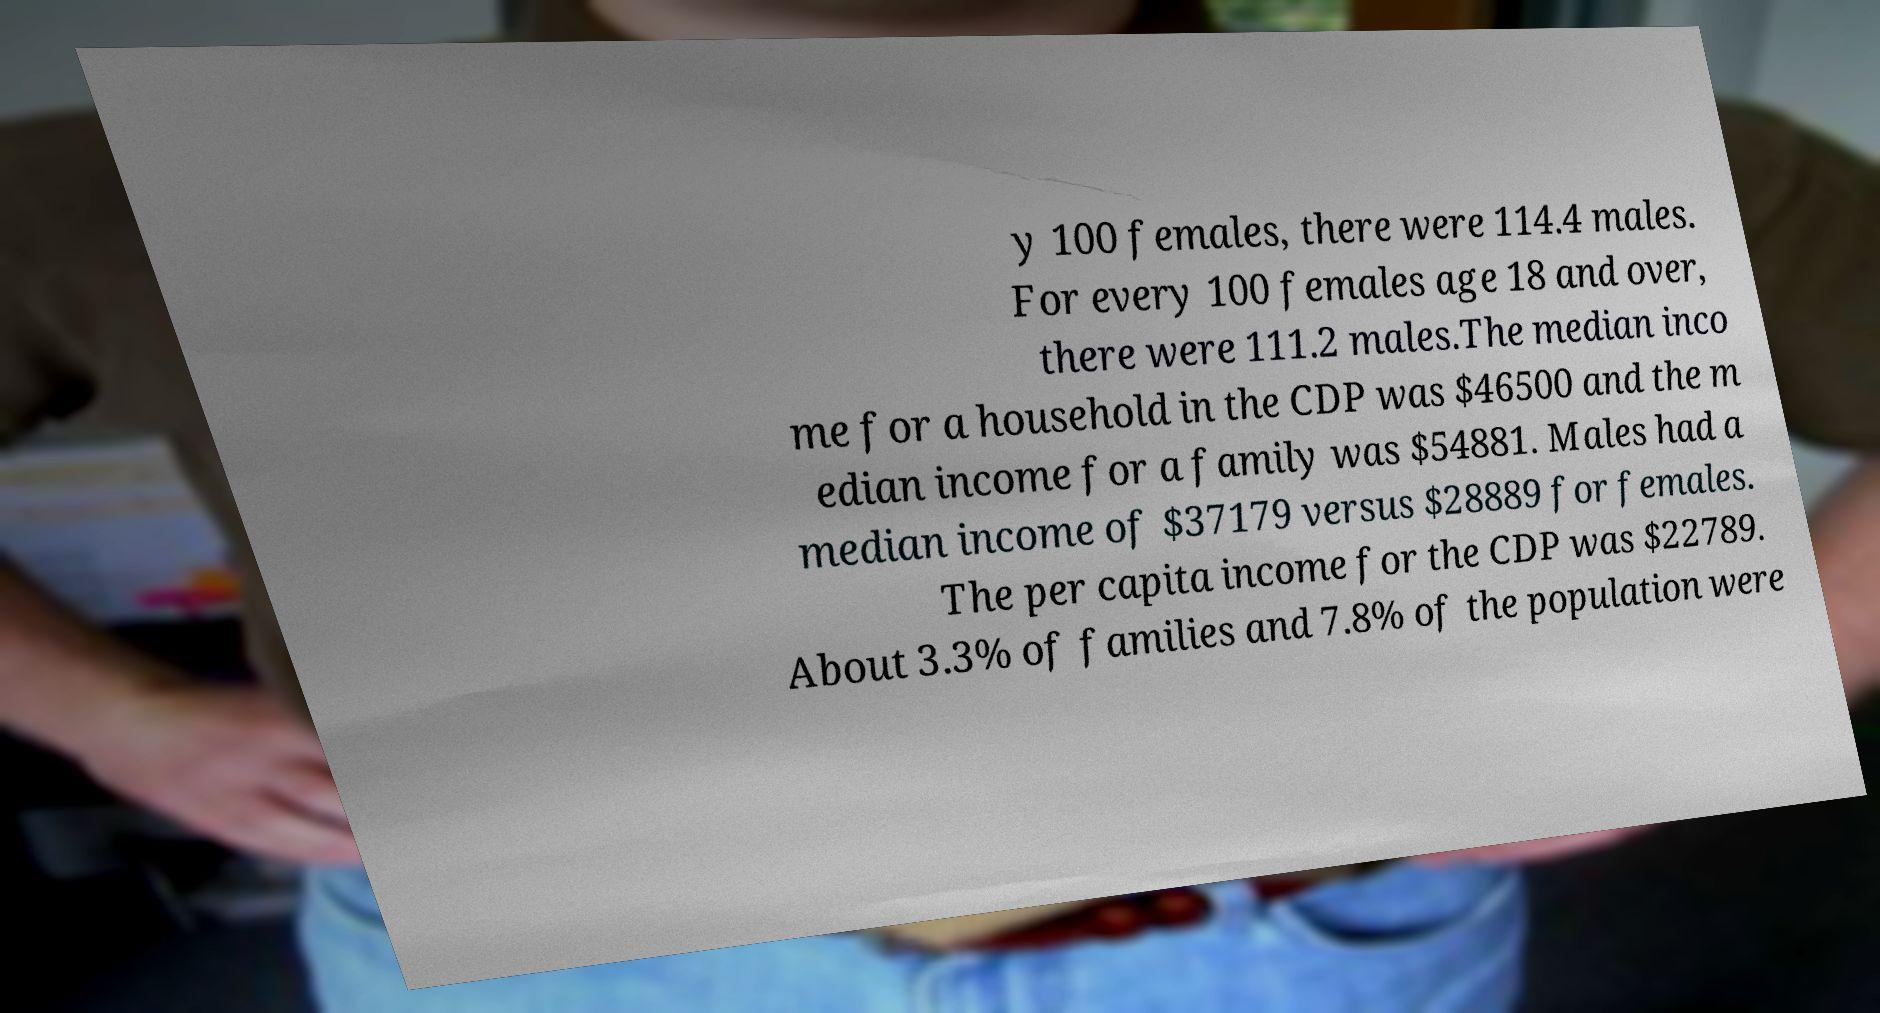There's text embedded in this image that I need extracted. Can you transcribe it verbatim? y 100 females, there were 114.4 males. For every 100 females age 18 and over, there were 111.2 males.The median inco me for a household in the CDP was $46500 and the m edian income for a family was $54881. Males had a median income of $37179 versus $28889 for females. The per capita income for the CDP was $22789. About 3.3% of families and 7.8% of the population were 